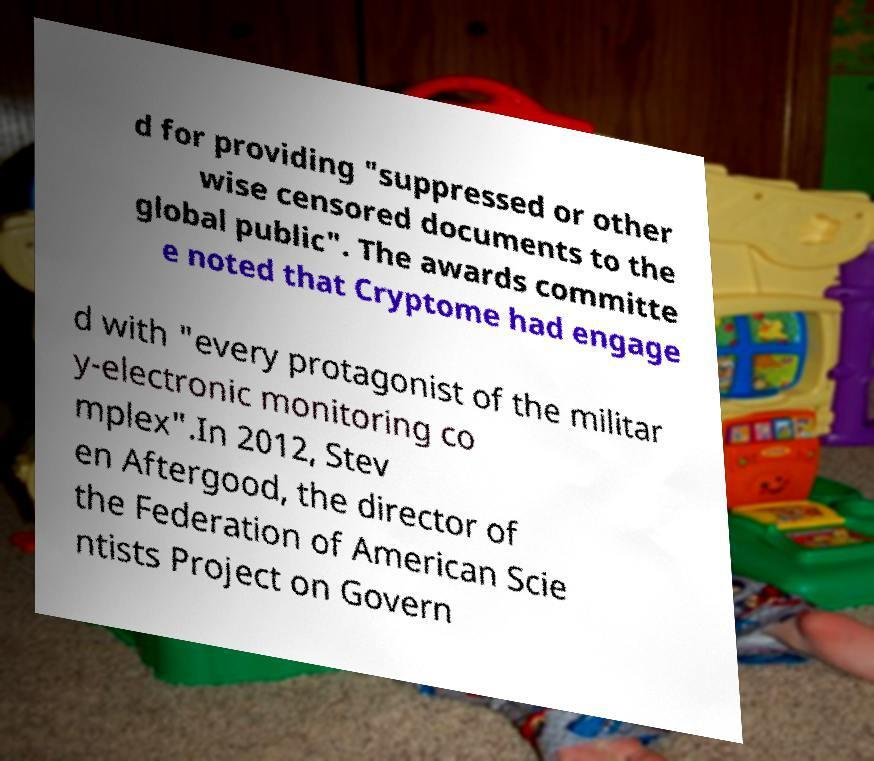Could you assist in decoding the text presented in this image and type it out clearly? d for providing "suppressed or other wise censored documents to the global public". The awards committe e noted that Cryptome had engage d with "every protagonist of the militar y-electronic monitoring co mplex".In 2012, Stev en Aftergood, the director of the Federation of American Scie ntists Project on Govern 